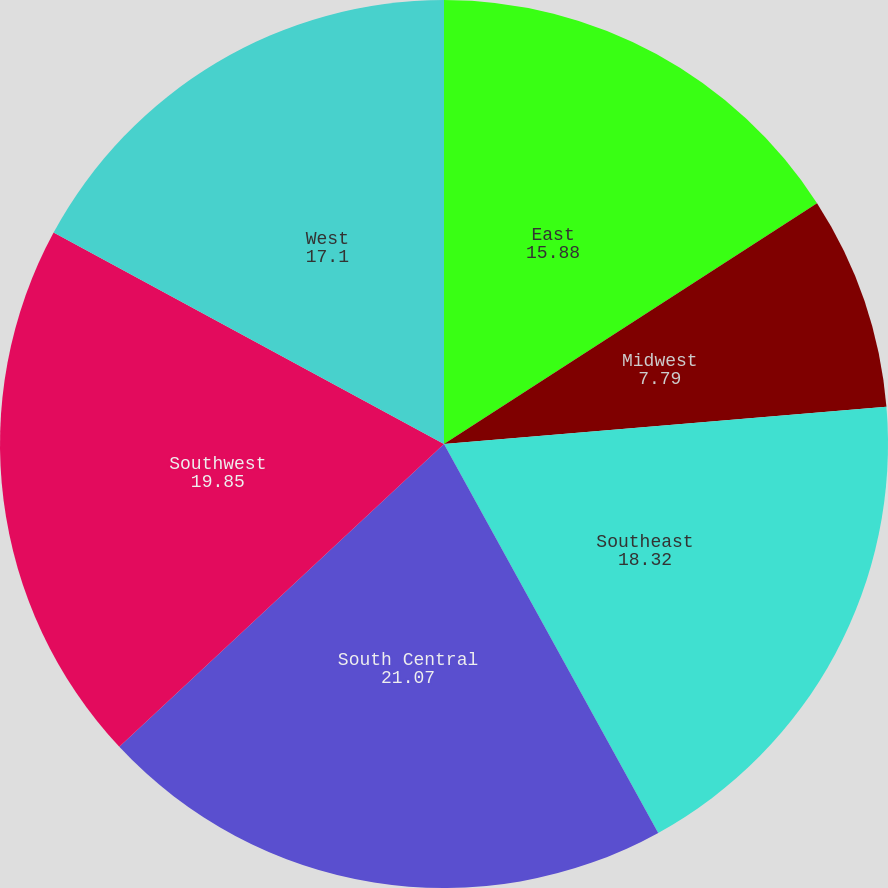Convert chart. <chart><loc_0><loc_0><loc_500><loc_500><pie_chart><fcel>East<fcel>Midwest<fcel>Southeast<fcel>South Central<fcel>Southwest<fcel>West<nl><fcel>15.88%<fcel>7.79%<fcel>18.32%<fcel>21.07%<fcel>19.85%<fcel>17.1%<nl></chart> 